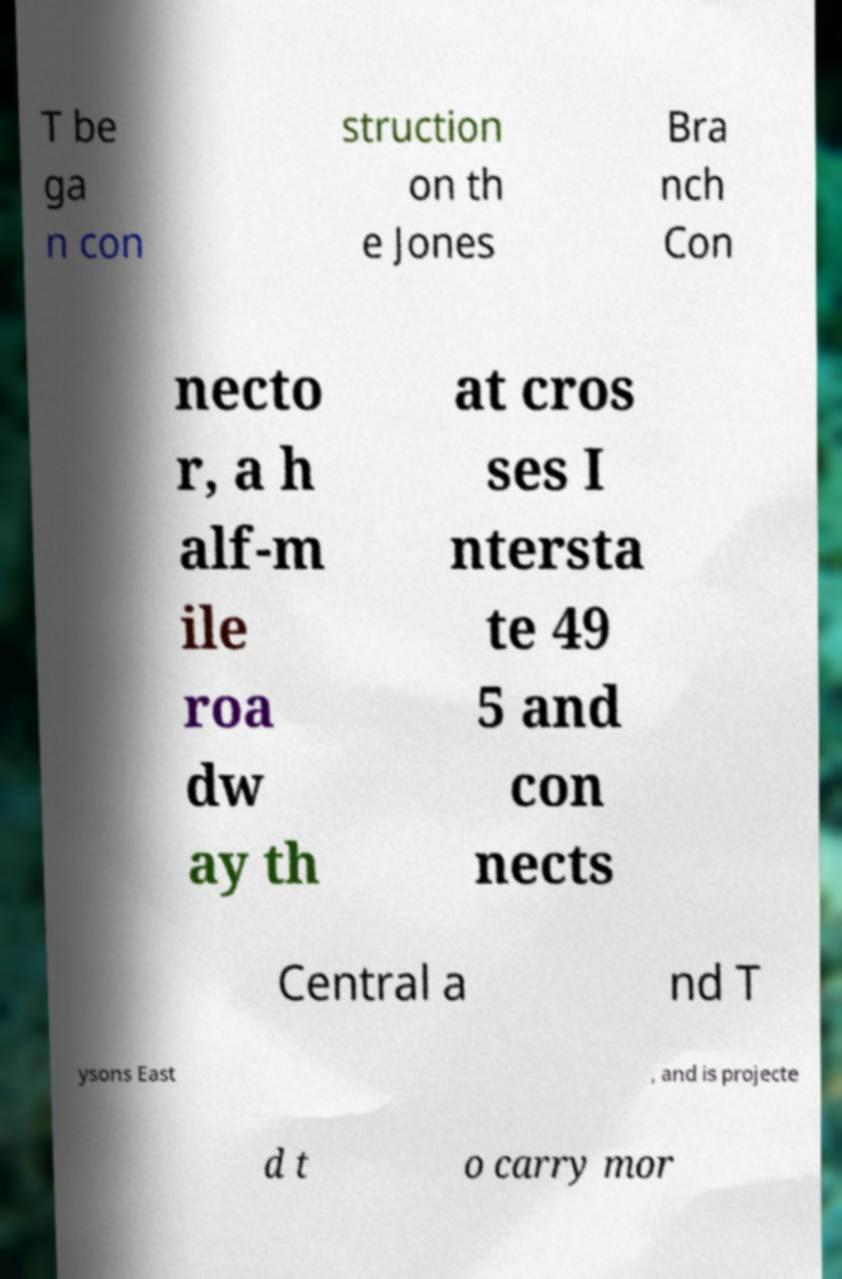I need the written content from this picture converted into text. Can you do that? T be ga n con struction on th e Jones Bra nch Con necto r, a h alf-m ile roa dw ay th at cros ses I ntersta te 49 5 and con nects Central a nd T ysons East , and is projecte d t o carry mor 